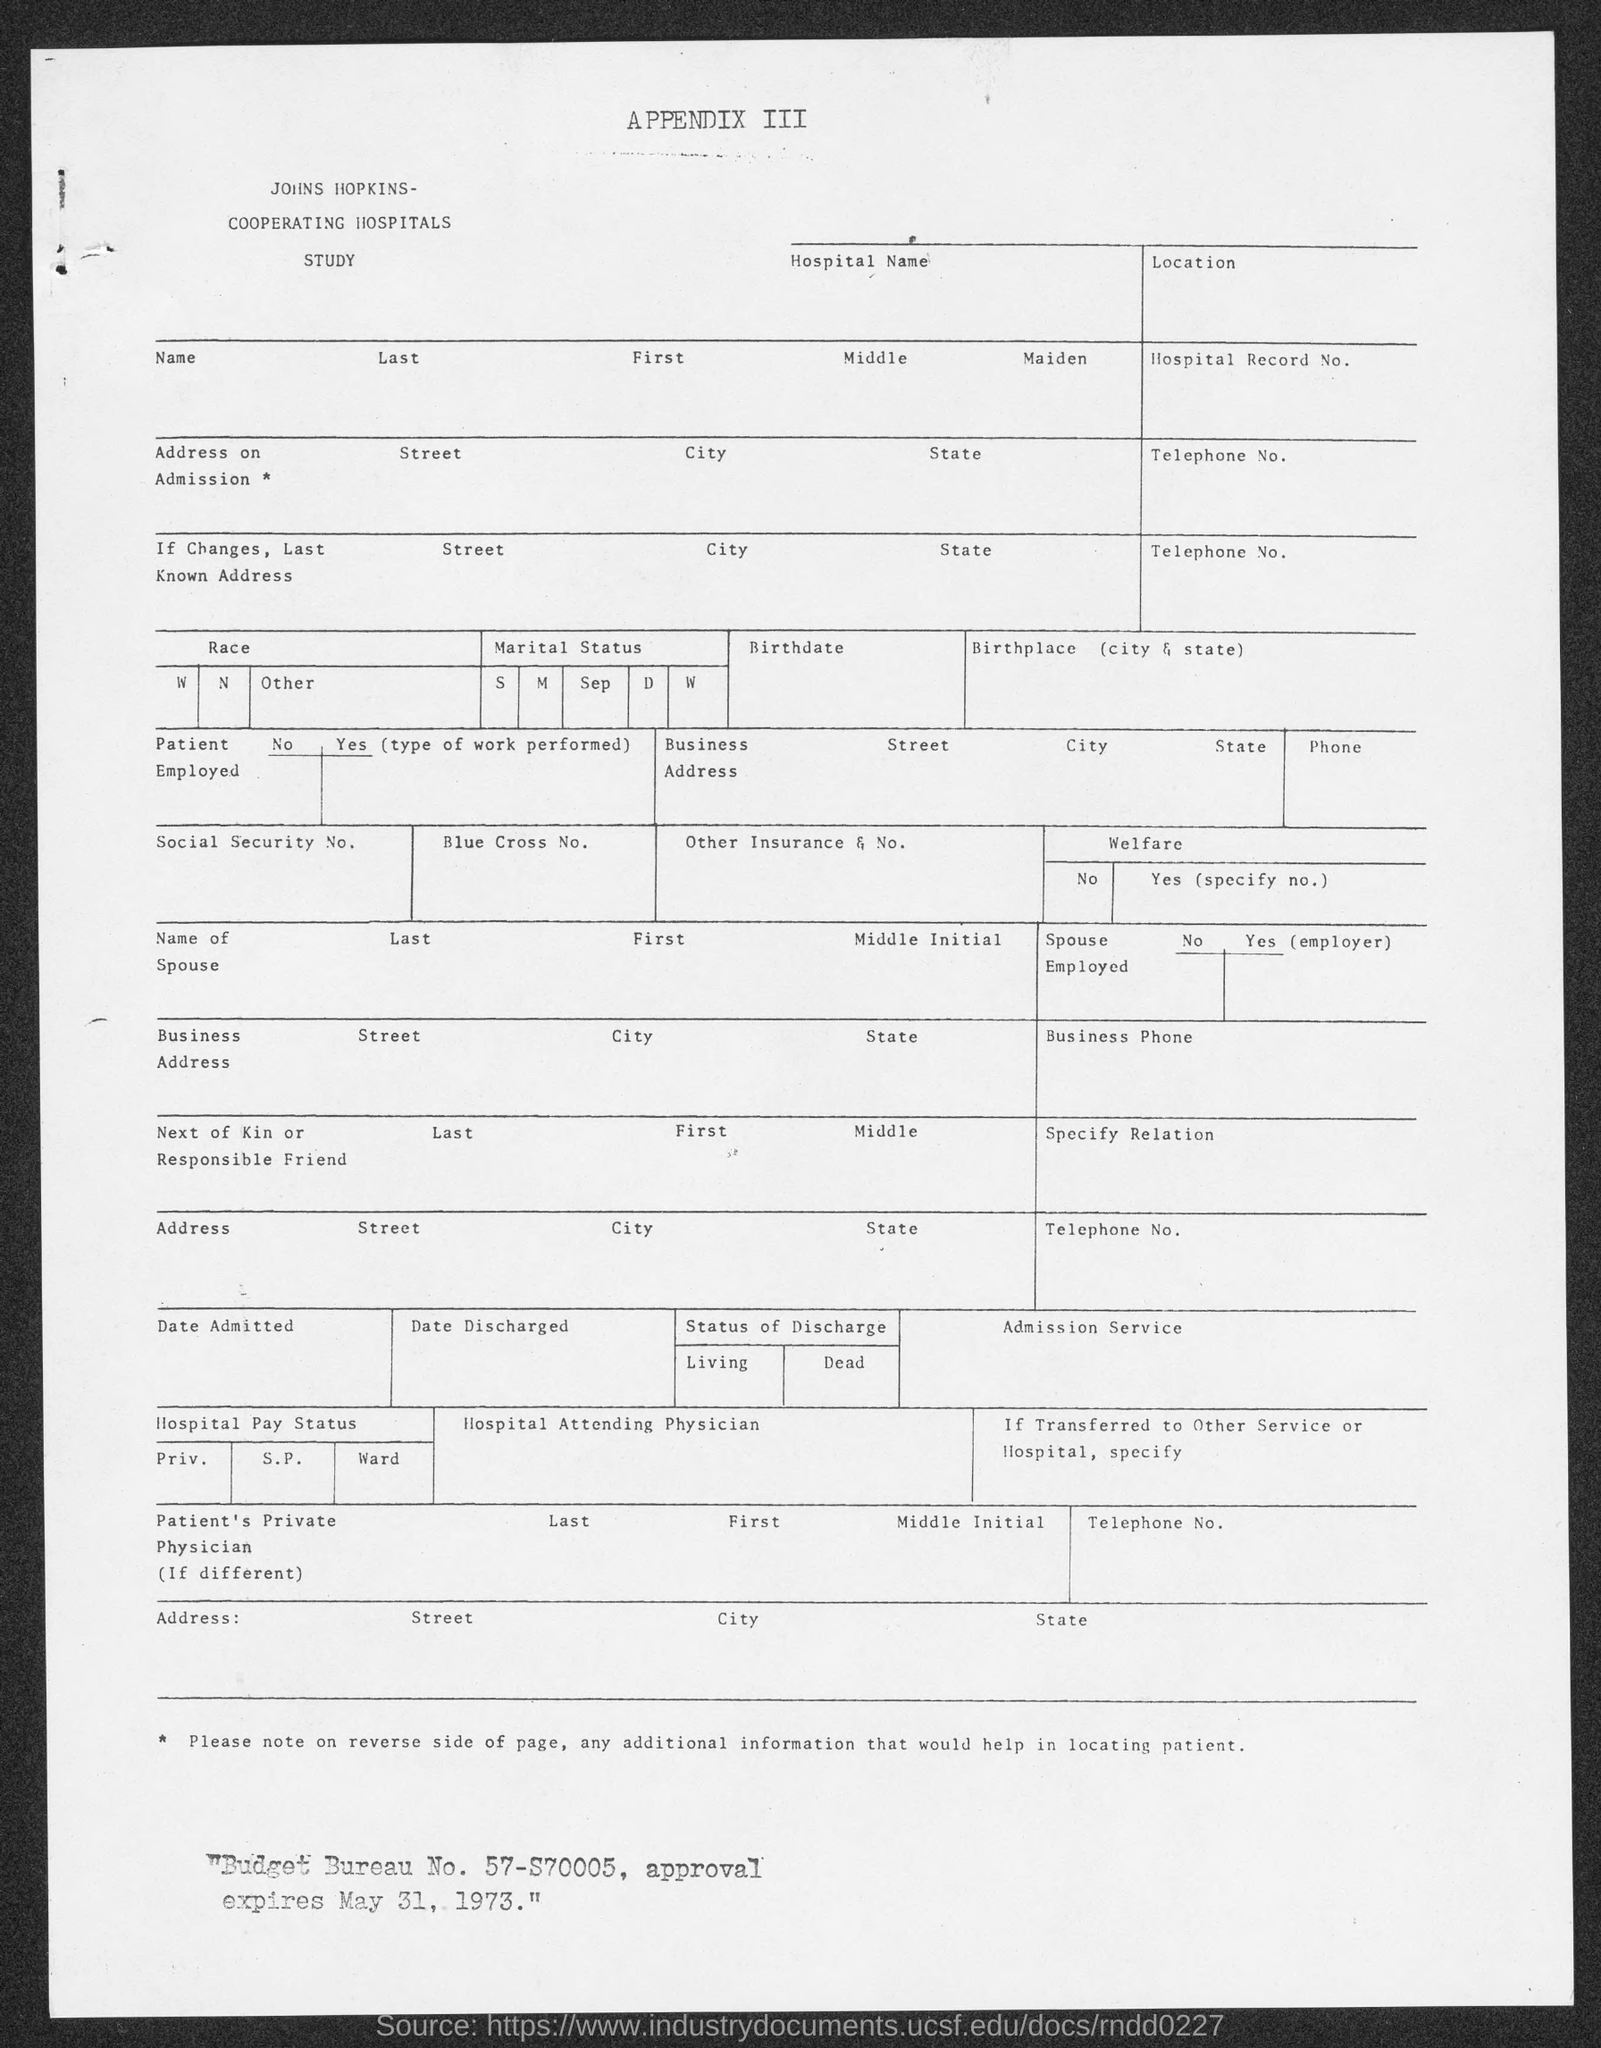Identify some key points in this picture. The budget bureau number is 57-S70005. 